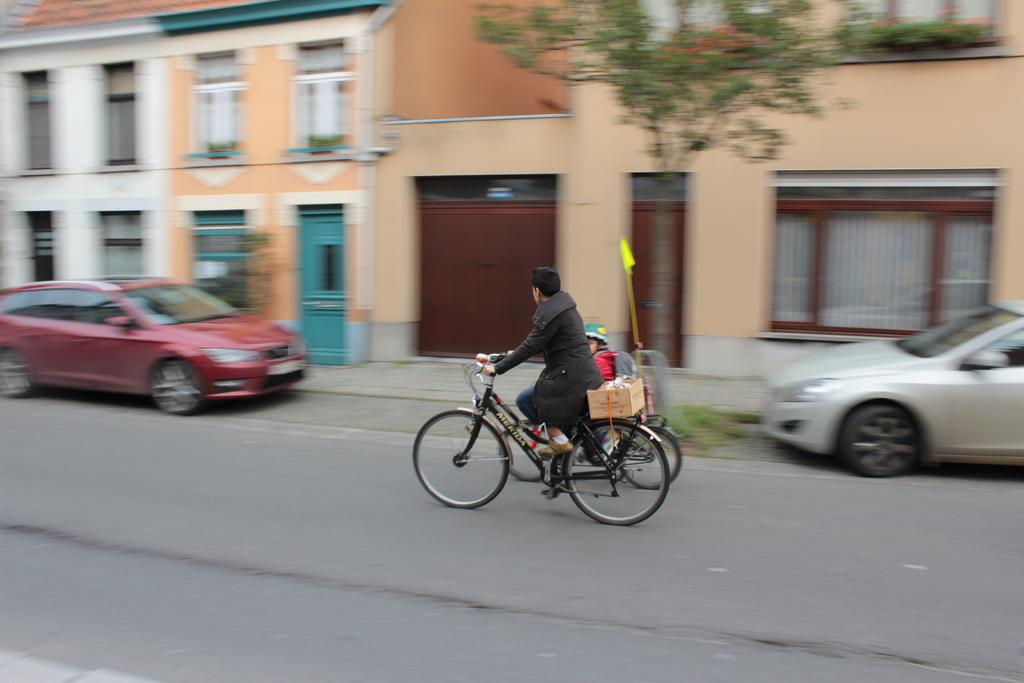What are the two persons in the image doing? The two persons in the image are cycling. Where are the cyclists located? The cyclists are on the road. What else can be seen in the image besides the cyclists? There are cars, buildings, and trees in the background of the image. What type of cactus can be seen in the image? There is no cactus present in the image. What time of day is it in the image, given the morning light? The provided facts do not mention the time of day or any specific lighting conditions, so it cannot be determined from the image. 